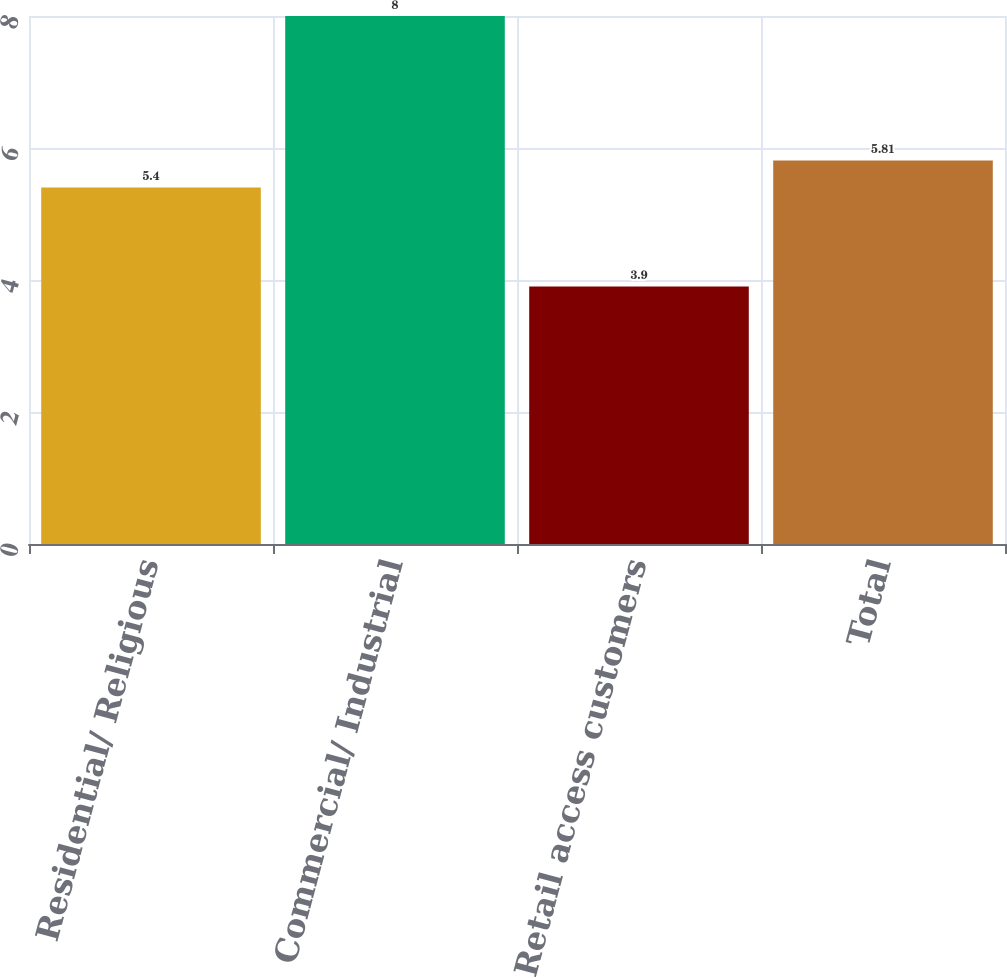Convert chart. <chart><loc_0><loc_0><loc_500><loc_500><bar_chart><fcel>Residential/ Religious<fcel>Commercial/ Industrial<fcel>Retail access customers<fcel>Total<nl><fcel>5.4<fcel>8<fcel>3.9<fcel>5.81<nl></chart> 